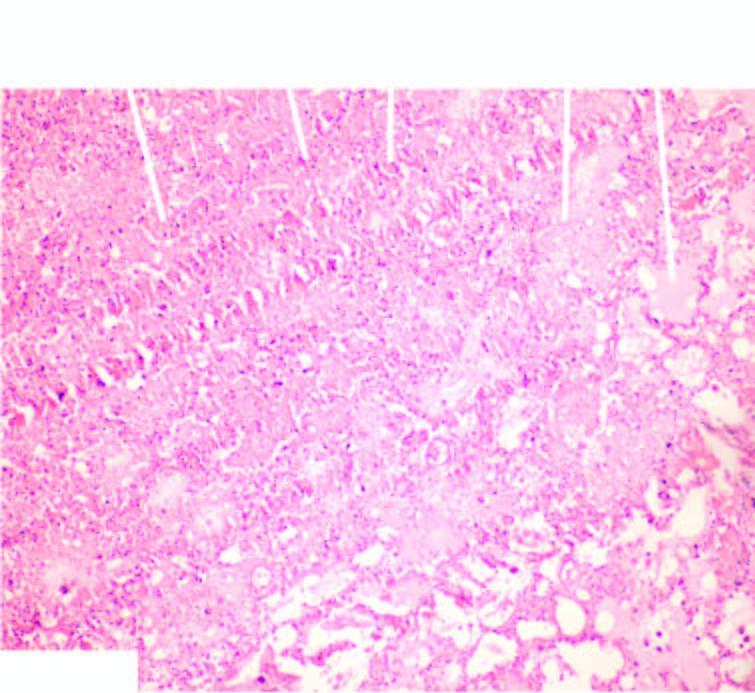what shows ghostal veoli filled with blood?
Answer the question using a single word or phrase. Infarcted area 